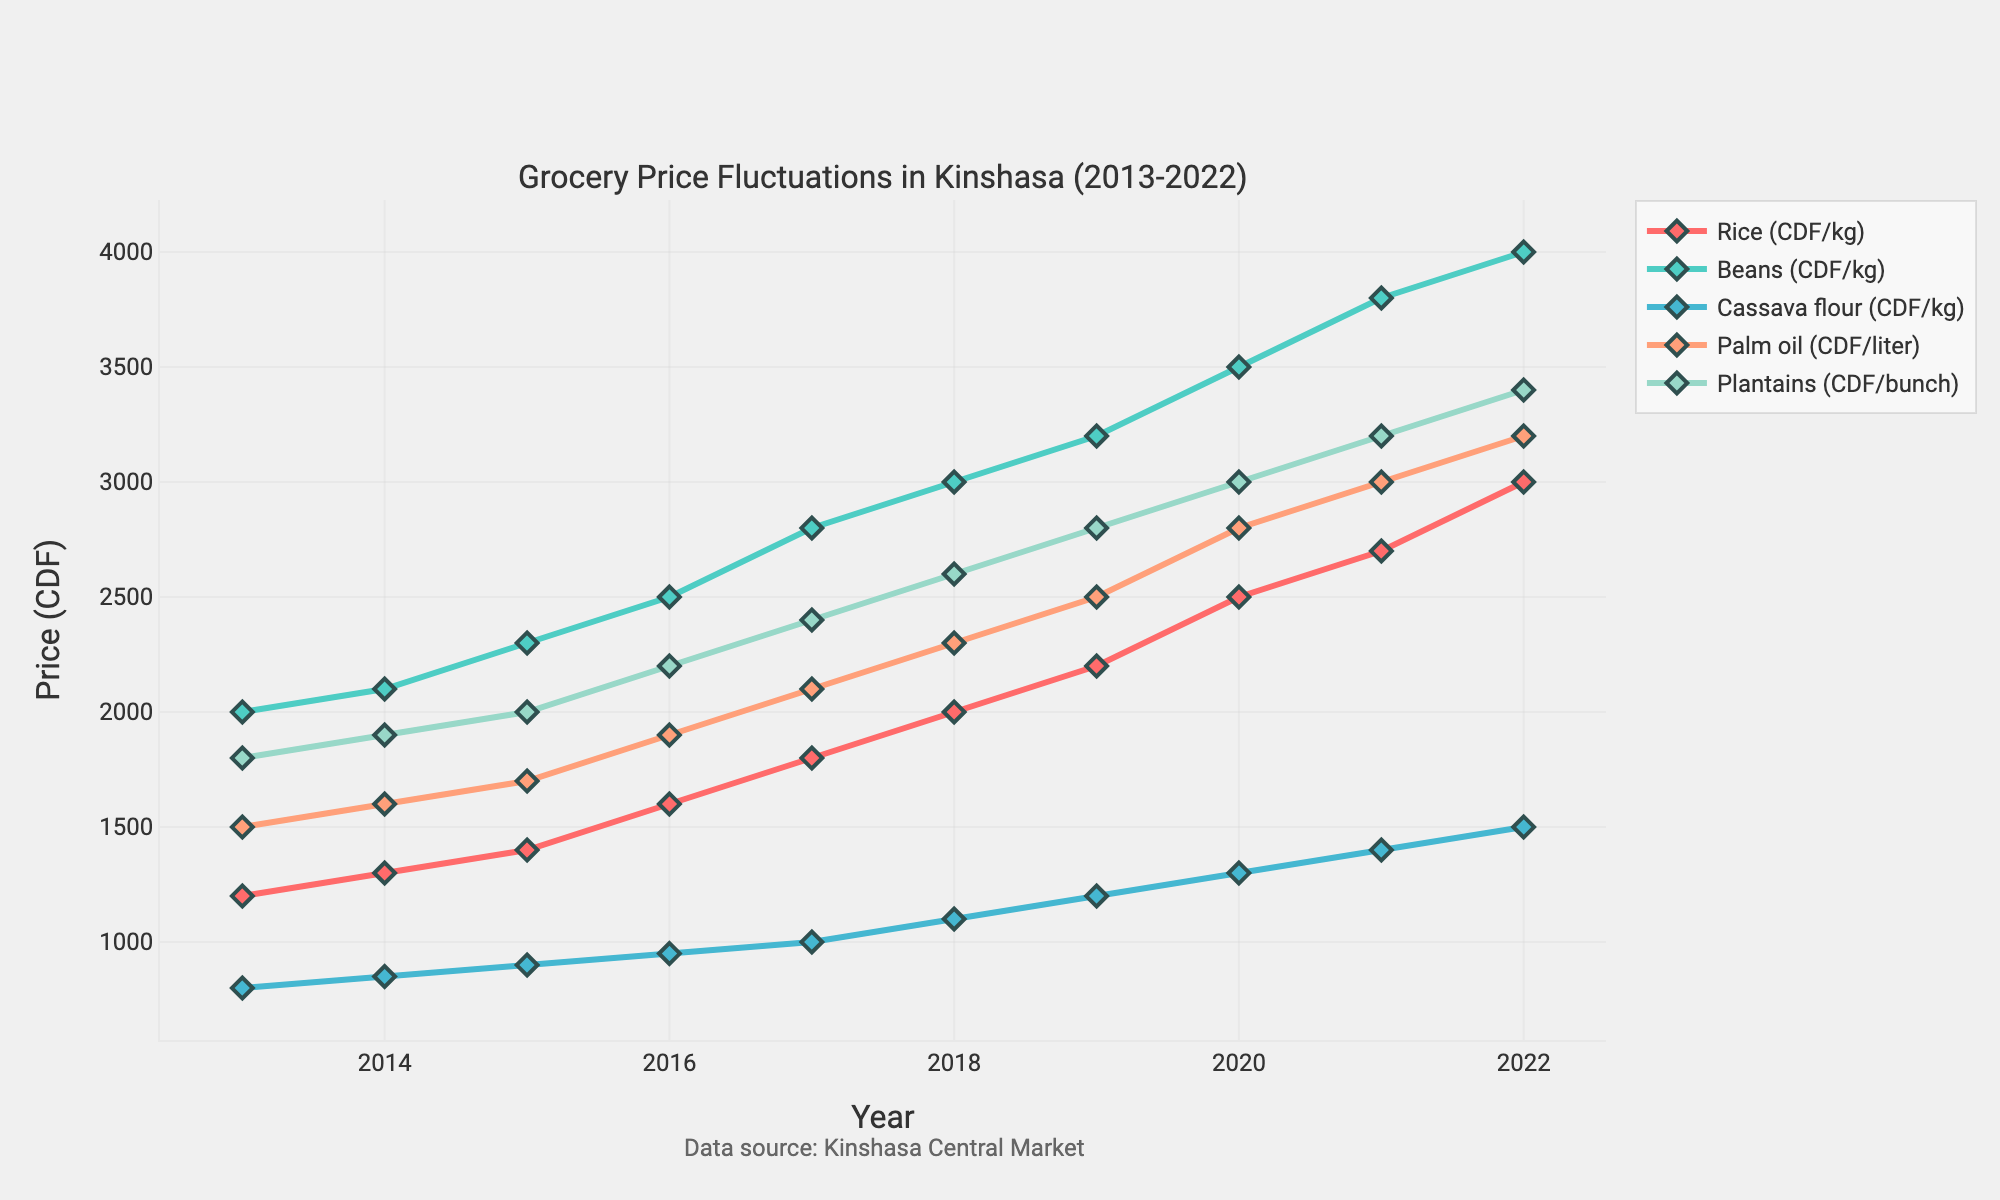What's the trend in the price of rice from 2013 to 2022? To find the trend, plot the line for rice from the start year 2013 to the end year 2022, then look for an overall direction in the chart. The rice price starts at 1200 CDF/kg in 2013 and increases each year to 3000 CDF/kg in 2022. This shows an increasing trend.
Answer: Increasing Which staple food had the highest price increase between 2013 and 2022? To determine which food had the highest price increase, subtract the 2013 price from the 2022 price for each food. Rice: 3000-1200=1800, Beans: 4000-2000=2000, Cassava flour: 1500-800=700, Palm oil: 3200-1500=1700, Plantains: 3400-1800=1600. Beans had the highest increase.
Answer: Beans What was the price difference between palm oil and plantains in 2020? Check the 2020 prices for palm oil and plantains. Palm oil was 2800 CDF/liter, and plantains were 3000 CDF/bunch. The difference is 3000 - 2800 = 200.
Answer: 200 In which year did cassava flour first reach over 1000 CDF per kg? Look at the line for cassava flour and identify the first year the price exceeds 1000 CDF/kg. In 2017, the price for cassava flour reached 1000 CDF/kg for the first time.
Answer: 2017 By how much did the price of beans increase from 2016 to 2021? To find this, subtract the 2016 price from the 2021 price for beans. Beans price in 2016 was 2500 CDF/kg, and in 2021 it was 3800 CDF/kg. Therefore, the increase is 3800 - 2500 = 1300.
Answer: 1300 Between rice and palm oil, which had a higher price in 2018? Compare the 2018 prices for rice and palm oil. Rice was 2000 CDF/kg, while palm oil was 2300 CDF/liter. Palm oil had a higher price.
Answer: Palm oil Calculate the average price of plantains from 2013 to 2022. Sum all the annual prices of plantains and then divide by the number of years. Prices: 1800+1900+2000+2200+2400+2600+2800+3000+3200+3400=25300. There are 10 years, so the average price is 25300/10 = 2530.
Answer: 2530 Was the price of beans ever less than that of rice? If so, in which years? Compare the prices of beans and rice each year. Beans were always more expensive than rice in each year from 2013 to 2022.
Answer: No 